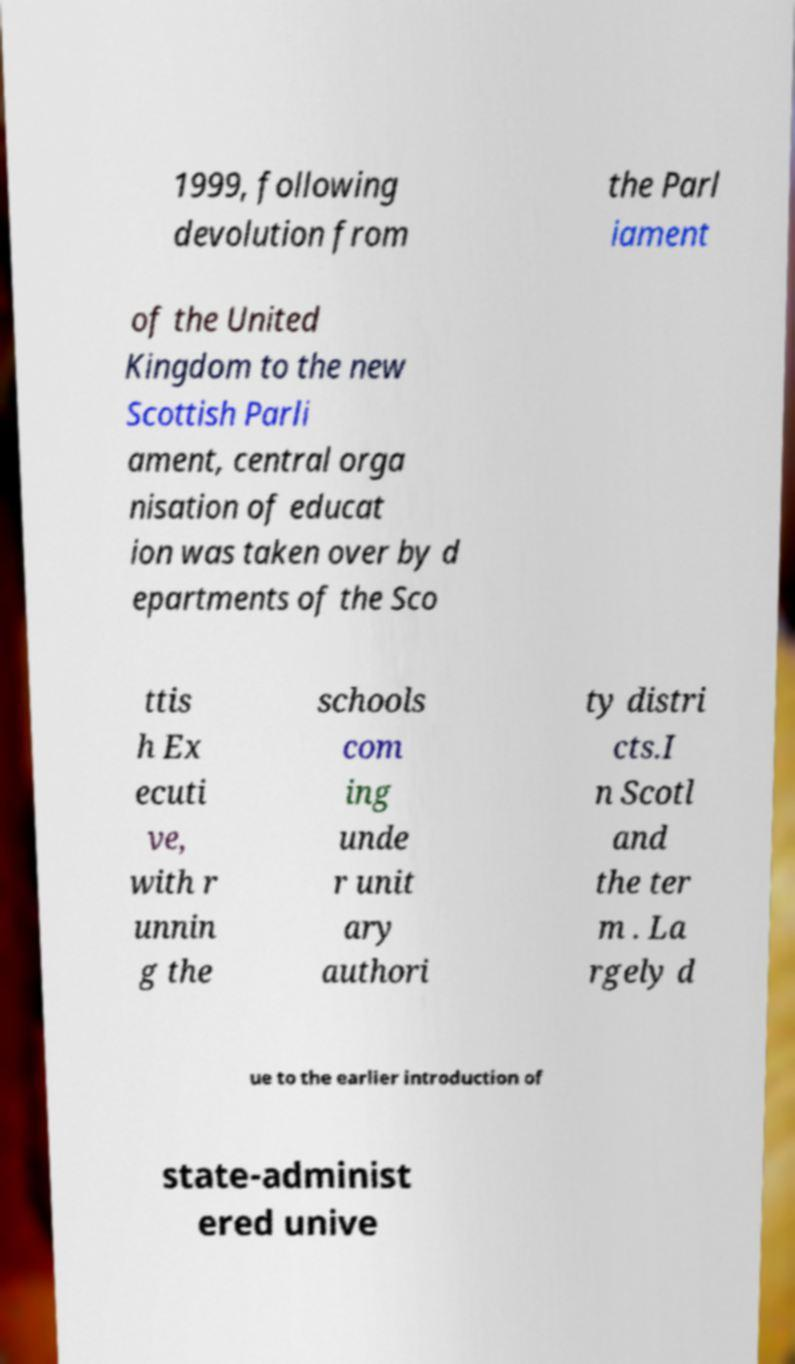For documentation purposes, I need the text within this image transcribed. Could you provide that? 1999, following devolution from the Parl iament of the United Kingdom to the new Scottish Parli ament, central orga nisation of educat ion was taken over by d epartments of the Sco ttis h Ex ecuti ve, with r unnin g the schools com ing unde r unit ary authori ty distri cts.I n Scotl and the ter m . La rgely d ue to the earlier introduction of state-administ ered unive 